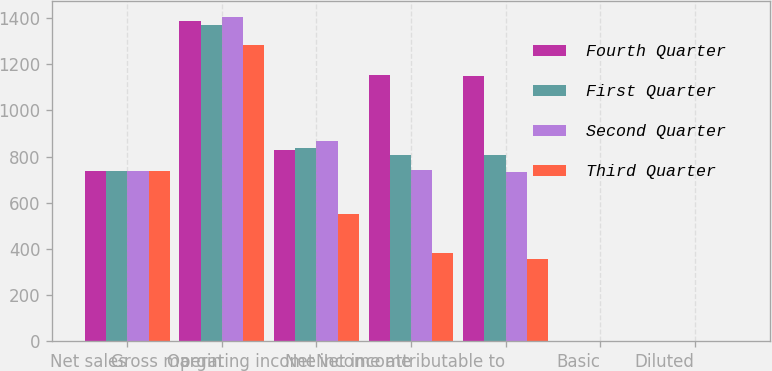Convert chart. <chart><loc_0><loc_0><loc_500><loc_500><stacked_bar_chart><ecel><fcel>Net sales<fcel>Gross margin<fcel>Operating income<fcel>Net income<fcel>Net income attributable to<fcel>Basic<fcel>Diluted<nl><fcel>Fourth Quarter<fcel>736<fcel>1385<fcel>828<fcel>1151<fcel>1150<fcel>1.08<fcel>0.96<nl><fcel>First Quarter<fcel>736<fcel>1368<fcel>839<fcel>806<fcel>806<fcel>0.76<fcel>0.68<nl><fcel>Second Quarter<fcel>736<fcel>1403<fcel>869<fcel>741<fcel>731<fcel>0.69<fcel>0.61<nl><fcel>Third Quarter<fcel>736<fcel>1281<fcel>551<fcel>381<fcel>358<fcel>0.34<fcel>0.3<nl></chart> 